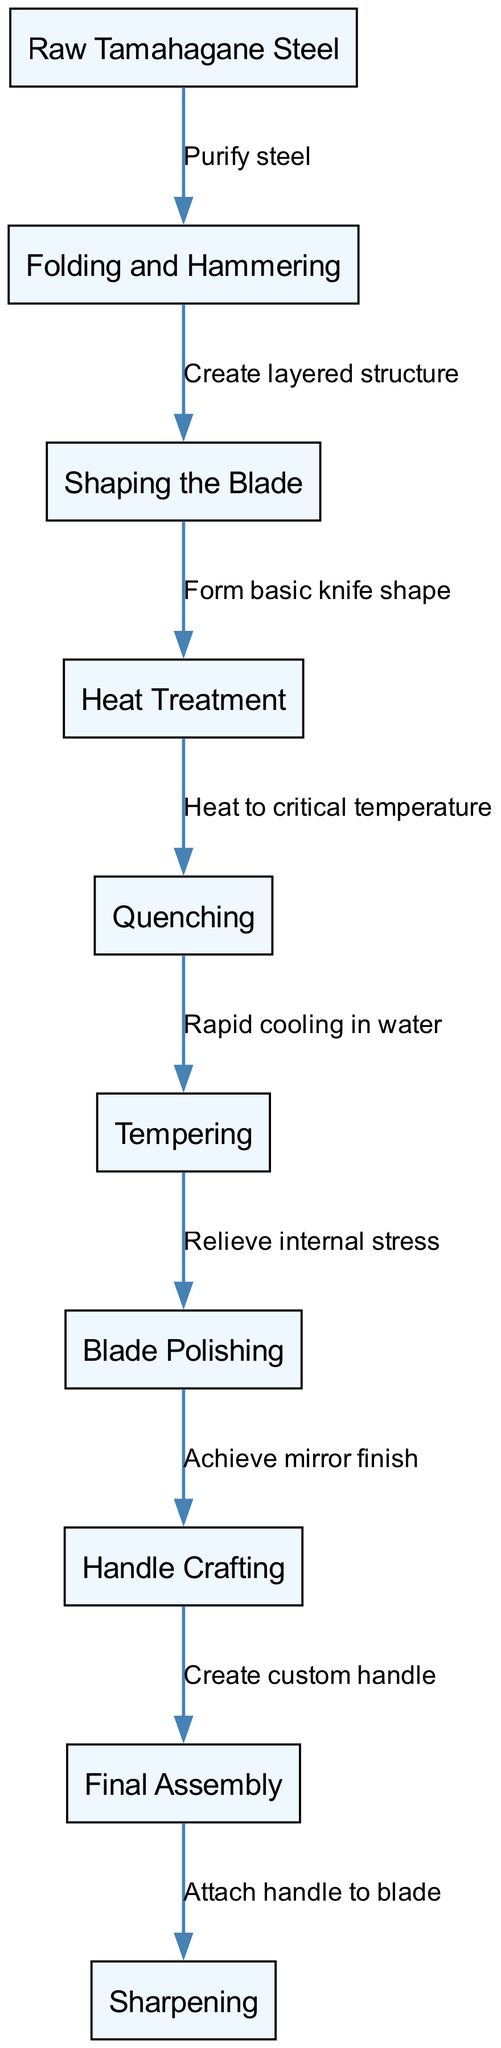What is the first step in the forging process? The diagram shows that the first step in the process is "Raw Tamahagane Steel." This is indicated as the starting node in the diagram, leading to the next process step.
Answer: Raw Tamahagane Steel How many nodes are present in the diagram? By counting each of the distinct circles (or "nodes") presented in the diagram, we can identify that there are a total of ten nodes.
Answer: 10 What is the relationship between "Heat Treatment" and "Quenching"? The diagram illustrates that "Heat Treatment" is connected to "Quenching" with the label "Heat to critical temperature." This indicates that the heat treatment step occurs before quenching.
Answer: Heat to critical temperature Which step comes after "Tempering"? Referring to the flow of the diagram, after "Tempering," the next step is "Blade Polishing." The edges indicate this progression.
Answer: Blade Polishing How are "Handle Crafting" and "Final Assembly" connected? The diagram shows that "Handle Crafting" leads directly to "Final Assembly," with the label "Create custom handle," indicating that crafting the handle is a prerequisite step before final assembly of the knife.
Answer: Create custom handle What step follows the "Quenching" process? Upon examining the diagram, "Quenching" is followed by "Tempering." The arrows show this direction of flow in the process.
Answer: Tempering Which step is responsible for achieving a mirror finish? In the diagram, "Blade Polishing" is specifically labeled as the step that achieves a mirror finish, making it clear that this process is dedicated to polishing the blade to that quality.
Answer: Blade Polishing What two processes are associated with relieving internal stress? The diagram indicates that "Tempering" leads into "Blade Polishing," but the keyword focusing on stress relief specifically is associated with "Tempering," as it is aimed at relieving internal stress inherent from the previous steps.
Answer: Tempering How many edges are there in the diagram? The edges represent the connections between the nodes, and by counting the lines connecting the nodes in the diagram, we find there are nine edges present.
Answer: 9 